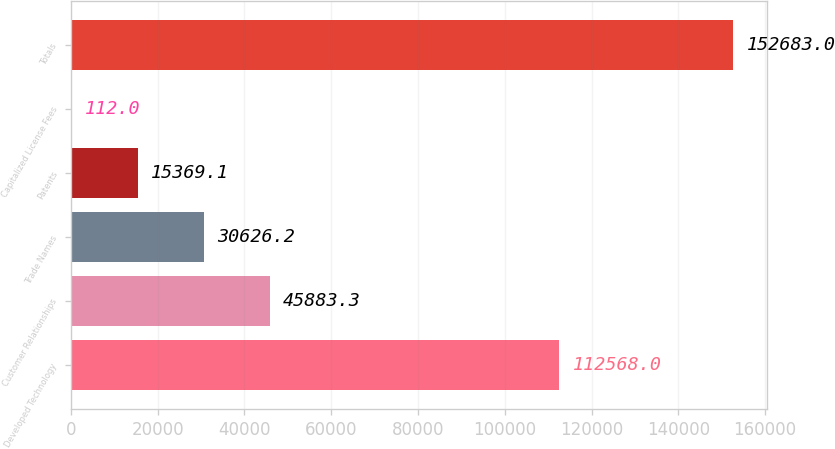Convert chart to OTSL. <chart><loc_0><loc_0><loc_500><loc_500><bar_chart><fcel>Developed Technology<fcel>Customer Relationships<fcel>Trade Names<fcel>Patents<fcel>Capitalized License Fees<fcel>Totals<nl><fcel>112568<fcel>45883.3<fcel>30626.2<fcel>15369.1<fcel>112<fcel>152683<nl></chart> 